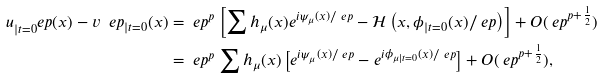<formula> <loc_0><loc_0><loc_500><loc_500>u _ { | t = 0 } ^ { \ } e p ( x ) - v ^ { \ } e p _ { | t = 0 } ( x ) & = \ e p ^ { p } \left [ \sum h _ { \mu } ( x ) e ^ { i \psi _ { \mu } ( x ) / \ e p } - \mathcal { H } \left ( x , \phi _ { | t = 0 } ( x ) / \ e p \right ) \right ] + O ( \ e p ^ { p + \frac { 1 } { 2 } } ) \\ & = \ e p ^ { p } \sum h _ { \mu } ( x ) \left [ e ^ { i \psi _ { \mu } ( x ) / \ e p } - e ^ { i \phi _ { \mu | t = 0 } ( x ) / \ e p } \right ] + O ( \ e p ^ { p + \frac { 1 } { 2 } } ) ,</formula> 